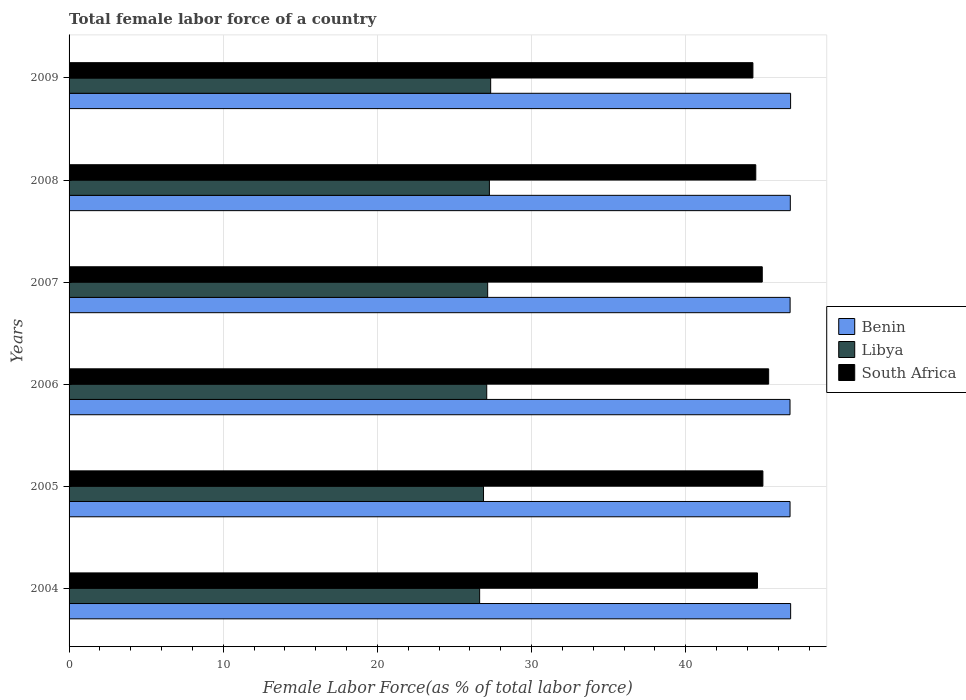What is the label of the 4th group of bars from the top?
Make the answer very short. 2006. In how many cases, is the number of bars for a given year not equal to the number of legend labels?
Give a very brief answer. 0. What is the percentage of female labor force in Benin in 2006?
Your response must be concise. 46.77. Across all years, what is the maximum percentage of female labor force in South Africa?
Provide a succinct answer. 45.38. Across all years, what is the minimum percentage of female labor force in South Africa?
Provide a succinct answer. 44.36. What is the total percentage of female labor force in Libya in the graph?
Give a very brief answer. 162.38. What is the difference between the percentage of female labor force in Benin in 2006 and that in 2008?
Offer a very short reply. -0.02. What is the difference between the percentage of female labor force in South Africa in 2009 and the percentage of female labor force in Libya in 2008?
Give a very brief answer. 17.09. What is the average percentage of female labor force in Benin per year?
Offer a terse response. 46.78. In the year 2005, what is the difference between the percentage of female labor force in South Africa and percentage of female labor force in Libya?
Offer a terse response. 18.12. What is the ratio of the percentage of female labor force in South Africa in 2008 to that in 2009?
Your answer should be very brief. 1. What is the difference between the highest and the second highest percentage of female labor force in South Africa?
Ensure brevity in your answer.  0.37. What is the difference between the highest and the lowest percentage of female labor force in Libya?
Your answer should be compact. 0.72. Is the sum of the percentage of female labor force in South Africa in 2005 and 2006 greater than the maximum percentage of female labor force in Libya across all years?
Your answer should be very brief. Yes. What does the 1st bar from the top in 2009 represents?
Offer a very short reply. South Africa. What does the 3rd bar from the bottom in 2007 represents?
Your response must be concise. South Africa. How many bars are there?
Make the answer very short. 18. How many years are there in the graph?
Your response must be concise. 6. Are the values on the major ticks of X-axis written in scientific E-notation?
Ensure brevity in your answer.  No. Where does the legend appear in the graph?
Your answer should be compact. Center right. How many legend labels are there?
Offer a very short reply. 3. What is the title of the graph?
Provide a succinct answer. Total female labor force of a country. What is the label or title of the X-axis?
Give a very brief answer. Female Labor Force(as % of total labor force). What is the label or title of the Y-axis?
Your answer should be very brief. Years. What is the Female Labor Force(as % of total labor force) of Benin in 2004?
Your answer should be very brief. 46.81. What is the Female Labor Force(as % of total labor force) in Libya in 2004?
Keep it short and to the point. 26.63. What is the Female Labor Force(as % of total labor force) in South Africa in 2004?
Your response must be concise. 44.66. What is the Female Labor Force(as % of total labor force) in Benin in 2005?
Make the answer very short. 46.77. What is the Female Labor Force(as % of total labor force) of Libya in 2005?
Your answer should be very brief. 26.88. What is the Female Labor Force(as % of total labor force) of South Africa in 2005?
Make the answer very short. 45.01. What is the Female Labor Force(as % of total labor force) of Benin in 2006?
Offer a terse response. 46.77. What is the Female Labor Force(as % of total labor force) of Libya in 2006?
Your response must be concise. 27.09. What is the Female Labor Force(as % of total labor force) in South Africa in 2006?
Make the answer very short. 45.38. What is the Female Labor Force(as % of total labor force) in Benin in 2007?
Make the answer very short. 46.77. What is the Female Labor Force(as % of total labor force) in Libya in 2007?
Ensure brevity in your answer.  27.15. What is the Female Labor Force(as % of total labor force) in South Africa in 2007?
Offer a terse response. 44.97. What is the Female Labor Force(as % of total labor force) in Benin in 2008?
Keep it short and to the point. 46.78. What is the Female Labor Force(as % of total labor force) of Libya in 2008?
Your answer should be compact. 27.27. What is the Female Labor Force(as % of total labor force) in South Africa in 2008?
Offer a very short reply. 44.54. What is the Female Labor Force(as % of total labor force) of Benin in 2009?
Offer a terse response. 46.8. What is the Female Labor Force(as % of total labor force) of Libya in 2009?
Your answer should be compact. 27.35. What is the Female Labor Force(as % of total labor force) in South Africa in 2009?
Provide a succinct answer. 44.36. Across all years, what is the maximum Female Labor Force(as % of total labor force) of Benin?
Keep it short and to the point. 46.81. Across all years, what is the maximum Female Labor Force(as % of total labor force) in Libya?
Offer a terse response. 27.35. Across all years, what is the maximum Female Labor Force(as % of total labor force) of South Africa?
Provide a short and direct response. 45.38. Across all years, what is the minimum Female Labor Force(as % of total labor force) in Benin?
Your response must be concise. 46.77. Across all years, what is the minimum Female Labor Force(as % of total labor force) of Libya?
Your response must be concise. 26.63. Across all years, what is the minimum Female Labor Force(as % of total labor force) of South Africa?
Provide a short and direct response. 44.36. What is the total Female Labor Force(as % of total labor force) in Benin in the graph?
Offer a terse response. 280.7. What is the total Female Labor Force(as % of total labor force) in Libya in the graph?
Your answer should be very brief. 162.38. What is the total Female Labor Force(as % of total labor force) in South Africa in the graph?
Offer a terse response. 268.91. What is the difference between the Female Labor Force(as % of total labor force) in Benin in 2004 and that in 2005?
Give a very brief answer. 0.04. What is the difference between the Female Labor Force(as % of total labor force) in Libya in 2004 and that in 2005?
Keep it short and to the point. -0.25. What is the difference between the Female Labor Force(as % of total labor force) in South Africa in 2004 and that in 2005?
Ensure brevity in your answer.  -0.35. What is the difference between the Female Labor Force(as % of total labor force) in Benin in 2004 and that in 2006?
Offer a terse response. 0.04. What is the difference between the Female Labor Force(as % of total labor force) in Libya in 2004 and that in 2006?
Your answer should be compact. -0.46. What is the difference between the Female Labor Force(as % of total labor force) of South Africa in 2004 and that in 2006?
Ensure brevity in your answer.  -0.72. What is the difference between the Female Labor Force(as % of total labor force) in Benin in 2004 and that in 2007?
Give a very brief answer. 0.03. What is the difference between the Female Labor Force(as % of total labor force) in Libya in 2004 and that in 2007?
Ensure brevity in your answer.  -0.52. What is the difference between the Female Labor Force(as % of total labor force) in South Africa in 2004 and that in 2007?
Keep it short and to the point. -0.31. What is the difference between the Female Labor Force(as % of total labor force) of Benin in 2004 and that in 2008?
Your response must be concise. 0.02. What is the difference between the Female Labor Force(as % of total labor force) of Libya in 2004 and that in 2008?
Offer a very short reply. -0.63. What is the difference between the Female Labor Force(as % of total labor force) in South Africa in 2004 and that in 2008?
Ensure brevity in your answer.  0.11. What is the difference between the Female Labor Force(as % of total labor force) in Benin in 2004 and that in 2009?
Provide a short and direct response. 0. What is the difference between the Female Labor Force(as % of total labor force) of Libya in 2004 and that in 2009?
Make the answer very short. -0.72. What is the difference between the Female Labor Force(as % of total labor force) in South Africa in 2004 and that in 2009?
Ensure brevity in your answer.  0.3. What is the difference between the Female Labor Force(as % of total labor force) in Benin in 2005 and that in 2006?
Your answer should be very brief. 0. What is the difference between the Female Labor Force(as % of total labor force) in Libya in 2005 and that in 2006?
Ensure brevity in your answer.  -0.21. What is the difference between the Female Labor Force(as % of total labor force) in South Africa in 2005 and that in 2006?
Make the answer very short. -0.37. What is the difference between the Female Labor Force(as % of total labor force) of Benin in 2005 and that in 2007?
Make the answer very short. -0. What is the difference between the Female Labor Force(as % of total labor force) in Libya in 2005 and that in 2007?
Provide a short and direct response. -0.27. What is the difference between the Female Labor Force(as % of total labor force) in South Africa in 2005 and that in 2007?
Your response must be concise. 0.04. What is the difference between the Female Labor Force(as % of total labor force) in Benin in 2005 and that in 2008?
Your answer should be compact. -0.02. What is the difference between the Female Labor Force(as % of total labor force) of Libya in 2005 and that in 2008?
Your answer should be compact. -0.38. What is the difference between the Female Labor Force(as % of total labor force) of South Africa in 2005 and that in 2008?
Give a very brief answer. 0.46. What is the difference between the Female Labor Force(as % of total labor force) of Benin in 2005 and that in 2009?
Make the answer very short. -0.04. What is the difference between the Female Labor Force(as % of total labor force) in Libya in 2005 and that in 2009?
Your response must be concise. -0.46. What is the difference between the Female Labor Force(as % of total labor force) of South Africa in 2005 and that in 2009?
Your answer should be very brief. 0.65. What is the difference between the Female Labor Force(as % of total labor force) of Benin in 2006 and that in 2007?
Provide a succinct answer. -0.01. What is the difference between the Female Labor Force(as % of total labor force) of Libya in 2006 and that in 2007?
Keep it short and to the point. -0.06. What is the difference between the Female Labor Force(as % of total labor force) of South Africa in 2006 and that in 2007?
Give a very brief answer. 0.41. What is the difference between the Female Labor Force(as % of total labor force) of Benin in 2006 and that in 2008?
Ensure brevity in your answer.  -0.02. What is the difference between the Female Labor Force(as % of total labor force) of Libya in 2006 and that in 2008?
Make the answer very short. -0.17. What is the difference between the Female Labor Force(as % of total labor force) in South Africa in 2006 and that in 2008?
Provide a succinct answer. 0.83. What is the difference between the Female Labor Force(as % of total labor force) of Benin in 2006 and that in 2009?
Make the answer very short. -0.04. What is the difference between the Female Labor Force(as % of total labor force) of Libya in 2006 and that in 2009?
Offer a very short reply. -0.26. What is the difference between the Female Labor Force(as % of total labor force) of South Africa in 2006 and that in 2009?
Provide a short and direct response. 1.02. What is the difference between the Female Labor Force(as % of total labor force) in Benin in 2007 and that in 2008?
Ensure brevity in your answer.  -0.01. What is the difference between the Female Labor Force(as % of total labor force) in Libya in 2007 and that in 2008?
Offer a terse response. -0.11. What is the difference between the Female Labor Force(as % of total labor force) of South Africa in 2007 and that in 2008?
Offer a terse response. 0.42. What is the difference between the Female Labor Force(as % of total labor force) in Benin in 2007 and that in 2009?
Your response must be concise. -0.03. What is the difference between the Female Labor Force(as % of total labor force) of Libya in 2007 and that in 2009?
Make the answer very short. -0.19. What is the difference between the Female Labor Force(as % of total labor force) in South Africa in 2007 and that in 2009?
Keep it short and to the point. 0.61. What is the difference between the Female Labor Force(as % of total labor force) of Benin in 2008 and that in 2009?
Ensure brevity in your answer.  -0.02. What is the difference between the Female Labor Force(as % of total labor force) in Libya in 2008 and that in 2009?
Provide a short and direct response. -0.08. What is the difference between the Female Labor Force(as % of total labor force) of South Africa in 2008 and that in 2009?
Make the answer very short. 0.19. What is the difference between the Female Labor Force(as % of total labor force) in Benin in 2004 and the Female Labor Force(as % of total labor force) in Libya in 2005?
Give a very brief answer. 19.92. What is the difference between the Female Labor Force(as % of total labor force) of Benin in 2004 and the Female Labor Force(as % of total labor force) of South Africa in 2005?
Ensure brevity in your answer.  1.8. What is the difference between the Female Labor Force(as % of total labor force) in Libya in 2004 and the Female Labor Force(as % of total labor force) in South Africa in 2005?
Your answer should be very brief. -18.37. What is the difference between the Female Labor Force(as % of total labor force) of Benin in 2004 and the Female Labor Force(as % of total labor force) of Libya in 2006?
Give a very brief answer. 19.71. What is the difference between the Female Labor Force(as % of total labor force) of Benin in 2004 and the Female Labor Force(as % of total labor force) of South Africa in 2006?
Offer a terse response. 1.43. What is the difference between the Female Labor Force(as % of total labor force) of Libya in 2004 and the Female Labor Force(as % of total labor force) of South Africa in 2006?
Ensure brevity in your answer.  -18.75. What is the difference between the Female Labor Force(as % of total labor force) in Benin in 2004 and the Female Labor Force(as % of total labor force) in Libya in 2007?
Make the answer very short. 19.65. What is the difference between the Female Labor Force(as % of total labor force) of Benin in 2004 and the Female Labor Force(as % of total labor force) of South Africa in 2007?
Offer a very short reply. 1.84. What is the difference between the Female Labor Force(as % of total labor force) in Libya in 2004 and the Female Labor Force(as % of total labor force) in South Africa in 2007?
Your answer should be compact. -18.33. What is the difference between the Female Labor Force(as % of total labor force) of Benin in 2004 and the Female Labor Force(as % of total labor force) of Libya in 2008?
Give a very brief answer. 19.54. What is the difference between the Female Labor Force(as % of total labor force) in Benin in 2004 and the Female Labor Force(as % of total labor force) in South Africa in 2008?
Provide a succinct answer. 2.26. What is the difference between the Female Labor Force(as % of total labor force) of Libya in 2004 and the Female Labor Force(as % of total labor force) of South Africa in 2008?
Make the answer very short. -17.91. What is the difference between the Female Labor Force(as % of total labor force) of Benin in 2004 and the Female Labor Force(as % of total labor force) of Libya in 2009?
Provide a succinct answer. 19.46. What is the difference between the Female Labor Force(as % of total labor force) in Benin in 2004 and the Female Labor Force(as % of total labor force) in South Africa in 2009?
Give a very brief answer. 2.45. What is the difference between the Female Labor Force(as % of total labor force) in Libya in 2004 and the Female Labor Force(as % of total labor force) in South Africa in 2009?
Offer a terse response. -17.73. What is the difference between the Female Labor Force(as % of total labor force) in Benin in 2005 and the Female Labor Force(as % of total labor force) in Libya in 2006?
Provide a succinct answer. 19.67. What is the difference between the Female Labor Force(as % of total labor force) in Benin in 2005 and the Female Labor Force(as % of total labor force) in South Africa in 2006?
Ensure brevity in your answer.  1.39. What is the difference between the Female Labor Force(as % of total labor force) in Libya in 2005 and the Female Labor Force(as % of total labor force) in South Africa in 2006?
Provide a short and direct response. -18.5. What is the difference between the Female Labor Force(as % of total labor force) of Benin in 2005 and the Female Labor Force(as % of total labor force) of Libya in 2007?
Your answer should be very brief. 19.61. What is the difference between the Female Labor Force(as % of total labor force) in Benin in 2005 and the Female Labor Force(as % of total labor force) in South Africa in 2007?
Offer a very short reply. 1.8. What is the difference between the Female Labor Force(as % of total labor force) of Libya in 2005 and the Female Labor Force(as % of total labor force) of South Africa in 2007?
Keep it short and to the point. -18.08. What is the difference between the Female Labor Force(as % of total labor force) in Benin in 2005 and the Female Labor Force(as % of total labor force) in Libya in 2008?
Your answer should be compact. 19.5. What is the difference between the Female Labor Force(as % of total labor force) in Benin in 2005 and the Female Labor Force(as % of total labor force) in South Africa in 2008?
Provide a short and direct response. 2.22. What is the difference between the Female Labor Force(as % of total labor force) in Libya in 2005 and the Female Labor Force(as % of total labor force) in South Africa in 2008?
Keep it short and to the point. -17.66. What is the difference between the Female Labor Force(as % of total labor force) of Benin in 2005 and the Female Labor Force(as % of total labor force) of Libya in 2009?
Your response must be concise. 19.42. What is the difference between the Female Labor Force(as % of total labor force) in Benin in 2005 and the Female Labor Force(as % of total labor force) in South Africa in 2009?
Provide a succinct answer. 2.41. What is the difference between the Female Labor Force(as % of total labor force) of Libya in 2005 and the Female Labor Force(as % of total labor force) of South Africa in 2009?
Your answer should be very brief. -17.47. What is the difference between the Female Labor Force(as % of total labor force) in Benin in 2006 and the Female Labor Force(as % of total labor force) in Libya in 2007?
Keep it short and to the point. 19.61. What is the difference between the Female Labor Force(as % of total labor force) of Benin in 2006 and the Female Labor Force(as % of total labor force) of South Africa in 2007?
Provide a short and direct response. 1.8. What is the difference between the Female Labor Force(as % of total labor force) in Libya in 2006 and the Female Labor Force(as % of total labor force) in South Africa in 2007?
Your answer should be compact. -17.87. What is the difference between the Female Labor Force(as % of total labor force) in Benin in 2006 and the Female Labor Force(as % of total labor force) in South Africa in 2008?
Offer a very short reply. 2.22. What is the difference between the Female Labor Force(as % of total labor force) in Libya in 2006 and the Female Labor Force(as % of total labor force) in South Africa in 2008?
Your response must be concise. -17.45. What is the difference between the Female Labor Force(as % of total labor force) in Benin in 2006 and the Female Labor Force(as % of total labor force) in Libya in 2009?
Provide a succinct answer. 19.42. What is the difference between the Female Labor Force(as % of total labor force) in Benin in 2006 and the Female Labor Force(as % of total labor force) in South Africa in 2009?
Keep it short and to the point. 2.41. What is the difference between the Female Labor Force(as % of total labor force) of Libya in 2006 and the Female Labor Force(as % of total labor force) of South Africa in 2009?
Make the answer very short. -17.27. What is the difference between the Female Labor Force(as % of total labor force) in Benin in 2007 and the Female Labor Force(as % of total labor force) in Libya in 2008?
Ensure brevity in your answer.  19.51. What is the difference between the Female Labor Force(as % of total labor force) in Benin in 2007 and the Female Labor Force(as % of total labor force) in South Africa in 2008?
Keep it short and to the point. 2.23. What is the difference between the Female Labor Force(as % of total labor force) in Libya in 2007 and the Female Labor Force(as % of total labor force) in South Africa in 2008?
Your response must be concise. -17.39. What is the difference between the Female Labor Force(as % of total labor force) in Benin in 2007 and the Female Labor Force(as % of total labor force) in Libya in 2009?
Keep it short and to the point. 19.42. What is the difference between the Female Labor Force(as % of total labor force) in Benin in 2007 and the Female Labor Force(as % of total labor force) in South Africa in 2009?
Offer a very short reply. 2.41. What is the difference between the Female Labor Force(as % of total labor force) in Libya in 2007 and the Female Labor Force(as % of total labor force) in South Africa in 2009?
Offer a very short reply. -17.2. What is the difference between the Female Labor Force(as % of total labor force) in Benin in 2008 and the Female Labor Force(as % of total labor force) in Libya in 2009?
Ensure brevity in your answer.  19.44. What is the difference between the Female Labor Force(as % of total labor force) in Benin in 2008 and the Female Labor Force(as % of total labor force) in South Africa in 2009?
Offer a very short reply. 2.43. What is the difference between the Female Labor Force(as % of total labor force) in Libya in 2008 and the Female Labor Force(as % of total labor force) in South Africa in 2009?
Your answer should be compact. -17.09. What is the average Female Labor Force(as % of total labor force) of Benin per year?
Give a very brief answer. 46.78. What is the average Female Labor Force(as % of total labor force) in Libya per year?
Your answer should be compact. 27.06. What is the average Female Labor Force(as % of total labor force) in South Africa per year?
Offer a very short reply. 44.82. In the year 2004, what is the difference between the Female Labor Force(as % of total labor force) of Benin and Female Labor Force(as % of total labor force) of Libya?
Your answer should be very brief. 20.17. In the year 2004, what is the difference between the Female Labor Force(as % of total labor force) in Benin and Female Labor Force(as % of total labor force) in South Africa?
Keep it short and to the point. 2.15. In the year 2004, what is the difference between the Female Labor Force(as % of total labor force) in Libya and Female Labor Force(as % of total labor force) in South Africa?
Make the answer very short. -18.02. In the year 2005, what is the difference between the Female Labor Force(as % of total labor force) of Benin and Female Labor Force(as % of total labor force) of Libya?
Keep it short and to the point. 19.88. In the year 2005, what is the difference between the Female Labor Force(as % of total labor force) in Benin and Female Labor Force(as % of total labor force) in South Africa?
Your answer should be compact. 1.76. In the year 2005, what is the difference between the Female Labor Force(as % of total labor force) in Libya and Female Labor Force(as % of total labor force) in South Africa?
Offer a very short reply. -18.12. In the year 2006, what is the difference between the Female Labor Force(as % of total labor force) of Benin and Female Labor Force(as % of total labor force) of Libya?
Give a very brief answer. 19.67. In the year 2006, what is the difference between the Female Labor Force(as % of total labor force) in Benin and Female Labor Force(as % of total labor force) in South Africa?
Your response must be concise. 1.39. In the year 2006, what is the difference between the Female Labor Force(as % of total labor force) in Libya and Female Labor Force(as % of total labor force) in South Africa?
Offer a terse response. -18.29. In the year 2007, what is the difference between the Female Labor Force(as % of total labor force) of Benin and Female Labor Force(as % of total labor force) of Libya?
Provide a succinct answer. 19.62. In the year 2007, what is the difference between the Female Labor Force(as % of total labor force) in Benin and Female Labor Force(as % of total labor force) in South Africa?
Provide a short and direct response. 1.81. In the year 2007, what is the difference between the Female Labor Force(as % of total labor force) in Libya and Female Labor Force(as % of total labor force) in South Africa?
Keep it short and to the point. -17.81. In the year 2008, what is the difference between the Female Labor Force(as % of total labor force) in Benin and Female Labor Force(as % of total labor force) in Libya?
Your answer should be compact. 19.52. In the year 2008, what is the difference between the Female Labor Force(as % of total labor force) in Benin and Female Labor Force(as % of total labor force) in South Africa?
Ensure brevity in your answer.  2.24. In the year 2008, what is the difference between the Female Labor Force(as % of total labor force) in Libya and Female Labor Force(as % of total labor force) in South Africa?
Your answer should be very brief. -17.28. In the year 2009, what is the difference between the Female Labor Force(as % of total labor force) of Benin and Female Labor Force(as % of total labor force) of Libya?
Offer a very short reply. 19.45. In the year 2009, what is the difference between the Female Labor Force(as % of total labor force) of Benin and Female Labor Force(as % of total labor force) of South Africa?
Keep it short and to the point. 2.44. In the year 2009, what is the difference between the Female Labor Force(as % of total labor force) of Libya and Female Labor Force(as % of total labor force) of South Africa?
Your response must be concise. -17.01. What is the ratio of the Female Labor Force(as % of total labor force) of Benin in 2004 to that in 2005?
Make the answer very short. 1. What is the ratio of the Female Labor Force(as % of total labor force) of Libya in 2004 to that in 2005?
Your answer should be very brief. 0.99. What is the ratio of the Female Labor Force(as % of total labor force) of South Africa in 2004 to that in 2005?
Make the answer very short. 0.99. What is the ratio of the Female Labor Force(as % of total labor force) in Benin in 2004 to that in 2006?
Make the answer very short. 1. What is the ratio of the Female Labor Force(as % of total labor force) of Libya in 2004 to that in 2006?
Give a very brief answer. 0.98. What is the ratio of the Female Labor Force(as % of total labor force) of Benin in 2004 to that in 2007?
Make the answer very short. 1. What is the ratio of the Female Labor Force(as % of total labor force) of Libya in 2004 to that in 2007?
Your answer should be very brief. 0.98. What is the ratio of the Female Labor Force(as % of total labor force) in South Africa in 2004 to that in 2007?
Offer a terse response. 0.99. What is the ratio of the Female Labor Force(as % of total labor force) in Libya in 2004 to that in 2008?
Give a very brief answer. 0.98. What is the ratio of the Female Labor Force(as % of total labor force) in South Africa in 2004 to that in 2008?
Your answer should be compact. 1. What is the ratio of the Female Labor Force(as % of total labor force) in Benin in 2004 to that in 2009?
Provide a short and direct response. 1. What is the ratio of the Female Labor Force(as % of total labor force) in Libya in 2004 to that in 2009?
Make the answer very short. 0.97. What is the ratio of the Female Labor Force(as % of total labor force) of South Africa in 2004 to that in 2009?
Provide a short and direct response. 1.01. What is the ratio of the Female Labor Force(as % of total labor force) in South Africa in 2005 to that in 2006?
Keep it short and to the point. 0.99. What is the ratio of the Female Labor Force(as % of total labor force) of Libya in 2005 to that in 2007?
Provide a succinct answer. 0.99. What is the ratio of the Female Labor Force(as % of total labor force) in South Africa in 2005 to that in 2007?
Your answer should be compact. 1. What is the ratio of the Female Labor Force(as % of total labor force) in Libya in 2005 to that in 2008?
Keep it short and to the point. 0.99. What is the ratio of the Female Labor Force(as % of total labor force) in South Africa in 2005 to that in 2008?
Your answer should be compact. 1.01. What is the ratio of the Female Labor Force(as % of total labor force) of Libya in 2005 to that in 2009?
Ensure brevity in your answer.  0.98. What is the ratio of the Female Labor Force(as % of total labor force) in South Africa in 2005 to that in 2009?
Your answer should be compact. 1.01. What is the ratio of the Female Labor Force(as % of total labor force) in Libya in 2006 to that in 2007?
Provide a succinct answer. 1. What is the ratio of the Female Labor Force(as % of total labor force) in South Africa in 2006 to that in 2007?
Offer a very short reply. 1.01. What is the ratio of the Female Labor Force(as % of total labor force) in Benin in 2006 to that in 2008?
Offer a very short reply. 1. What is the ratio of the Female Labor Force(as % of total labor force) in Libya in 2006 to that in 2008?
Offer a very short reply. 0.99. What is the ratio of the Female Labor Force(as % of total labor force) of South Africa in 2006 to that in 2008?
Provide a succinct answer. 1.02. What is the ratio of the Female Labor Force(as % of total labor force) in Benin in 2006 to that in 2009?
Provide a succinct answer. 1. What is the ratio of the Female Labor Force(as % of total labor force) in Libya in 2006 to that in 2009?
Make the answer very short. 0.99. What is the ratio of the Female Labor Force(as % of total labor force) in South Africa in 2006 to that in 2009?
Offer a terse response. 1.02. What is the ratio of the Female Labor Force(as % of total labor force) of Benin in 2007 to that in 2008?
Ensure brevity in your answer.  1. What is the ratio of the Female Labor Force(as % of total labor force) in South Africa in 2007 to that in 2008?
Provide a succinct answer. 1.01. What is the ratio of the Female Labor Force(as % of total labor force) of Libya in 2007 to that in 2009?
Your response must be concise. 0.99. What is the ratio of the Female Labor Force(as % of total labor force) in South Africa in 2007 to that in 2009?
Ensure brevity in your answer.  1.01. What is the ratio of the Female Labor Force(as % of total labor force) of Libya in 2008 to that in 2009?
Your answer should be very brief. 1. What is the difference between the highest and the second highest Female Labor Force(as % of total labor force) in Benin?
Keep it short and to the point. 0. What is the difference between the highest and the second highest Female Labor Force(as % of total labor force) of Libya?
Keep it short and to the point. 0.08. What is the difference between the highest and the second highest Female Labor Force(as % of total labor force) in South Africa?
Offer a terse response. 0.37. What is the difference between the highest and the lowest Female Labor Force(as % of total labor force) of Benin?
Offer a terse response. 0.04. What is the difference between the highest and the lowest Female Labor Force(as % of total labor force) in Libya?
Offer a terse response. 0.72. What is the difference between the highest and the lowest Female Labor Force(as % of total labor force) in South Africa?
Give a very brief answer. 1.02. 